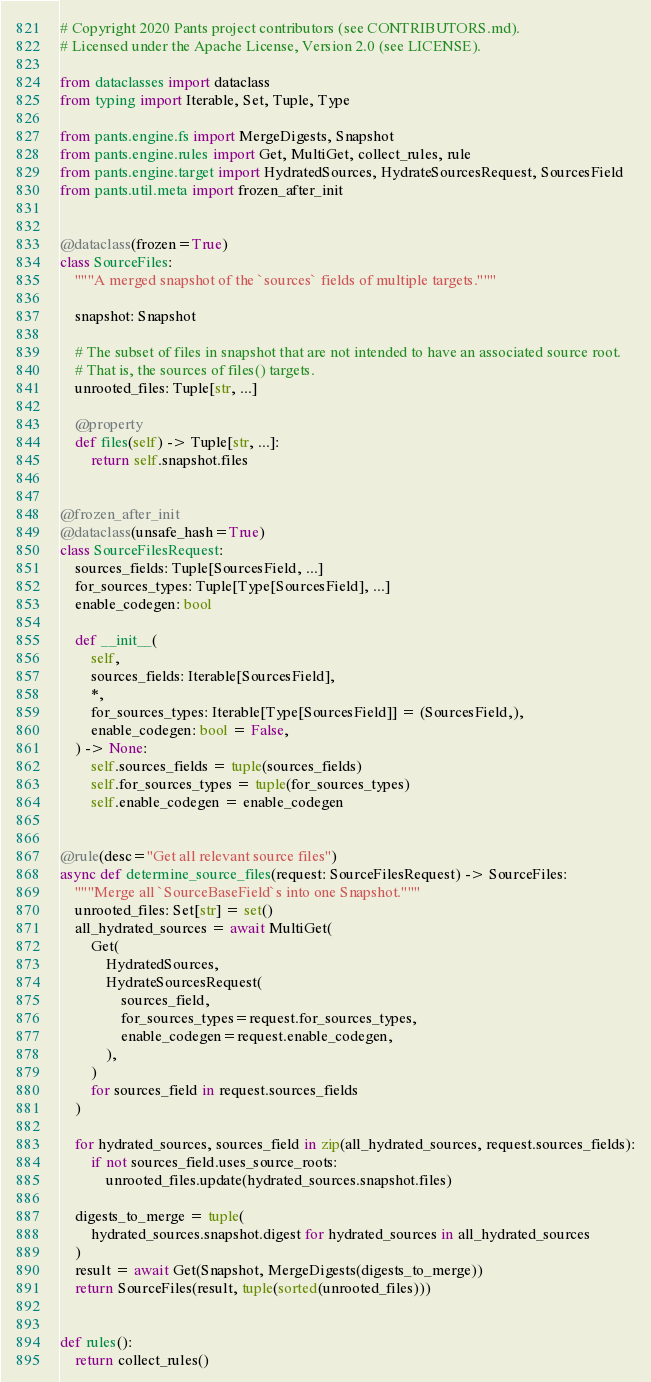Convert code to text. <code><loc_0><loc_0><loc_500><loc_500><_Python_># Copyright 2020 Pants project contributors (see CONTRIBUTORS.md).
# Licensed under the Apache License, Version 2.0 (see LICENSE).

from dataclasses import dataclass
from typing import Iterable, Set, Tuple, Type

from pants.engine.fs import MergeDigests, Snapshot
from pants.engine.rules import Get, MultiGet, collect_rules, rule
from pants.engine.target import HydratedSources, HydrateSourcesRequest, SourcesField
from pants.util.meta import frozen_after_init


@dataclass(frozen=True)
class SourceFiles:
    """A merged snapshot of the `sources` fields of multiple targets."""

    snapshot: Snapshot

    # The subset of files in snapshot that are not intended to have an associated source root.
    # That is, the sources of files() targets.
    unrooted_files: Tuple[str, ...]

    @property
    def files(self) -> Tuple[str, ...]:
        return self.snapshot.files


@frozen_after_init
@dataclass(unsafe_hash=True)
class SourceFilesRequest:
    sources_fields: Tuple[SourcesField, ...]
    for_sources_types: Tuple[Type[SourcesField], ...]
    enable_codegen: bool

    def __init__(
        self,
        sources_fields: Iterable[SourcesField],
        *,
        for_sources_types: Iterable[Type[SourcesField]] = (SourcesField,),
        enable_codegen: bool = False,
    ) -> None:
        self.sources_fields = tuple(sources_fields)
        self.for_sources_types = tuple(for_sources_types)
        self.enable_codegen = enable_codegen


@rule(desc="Get all relevant source files")
async def determine_source_files(request: SourceFilesRequest) -> SourceFiles:
    """Merge all `SourceBaseField`s into one Snapshot."""
    unrooted_files: Set[str] = set()
    all_hydrated_sources = await MultiGet(
        Get(
            HydratedSources,
            HydrateSourcesRequest(
                sources_field,
                for_sources_types=request.for_sources_types,
                enable_codegen=request.enable_codegen,
            ),
        )
        for sources_field in request.sources_fields
    )

    for hydrated_sources, sources_field in zip(all_hydrated_sources, request.sources_fields):
        if not sources_field.uses_source_roots:
            unrooted_files.update(hydrated_sources.snapshot.files)

    digests_to_merge = tuple(
        hydrated_sources.snapshot.digest for hydrated_sources in all_hydrated_sources
    )
    result = await Get(Snapshot, MergeDigests(digests_to_merge))
    return SourceFiles(result, tuple(sorted(unrooted_files)))


def rules():
    return collect_rules()
</code> 